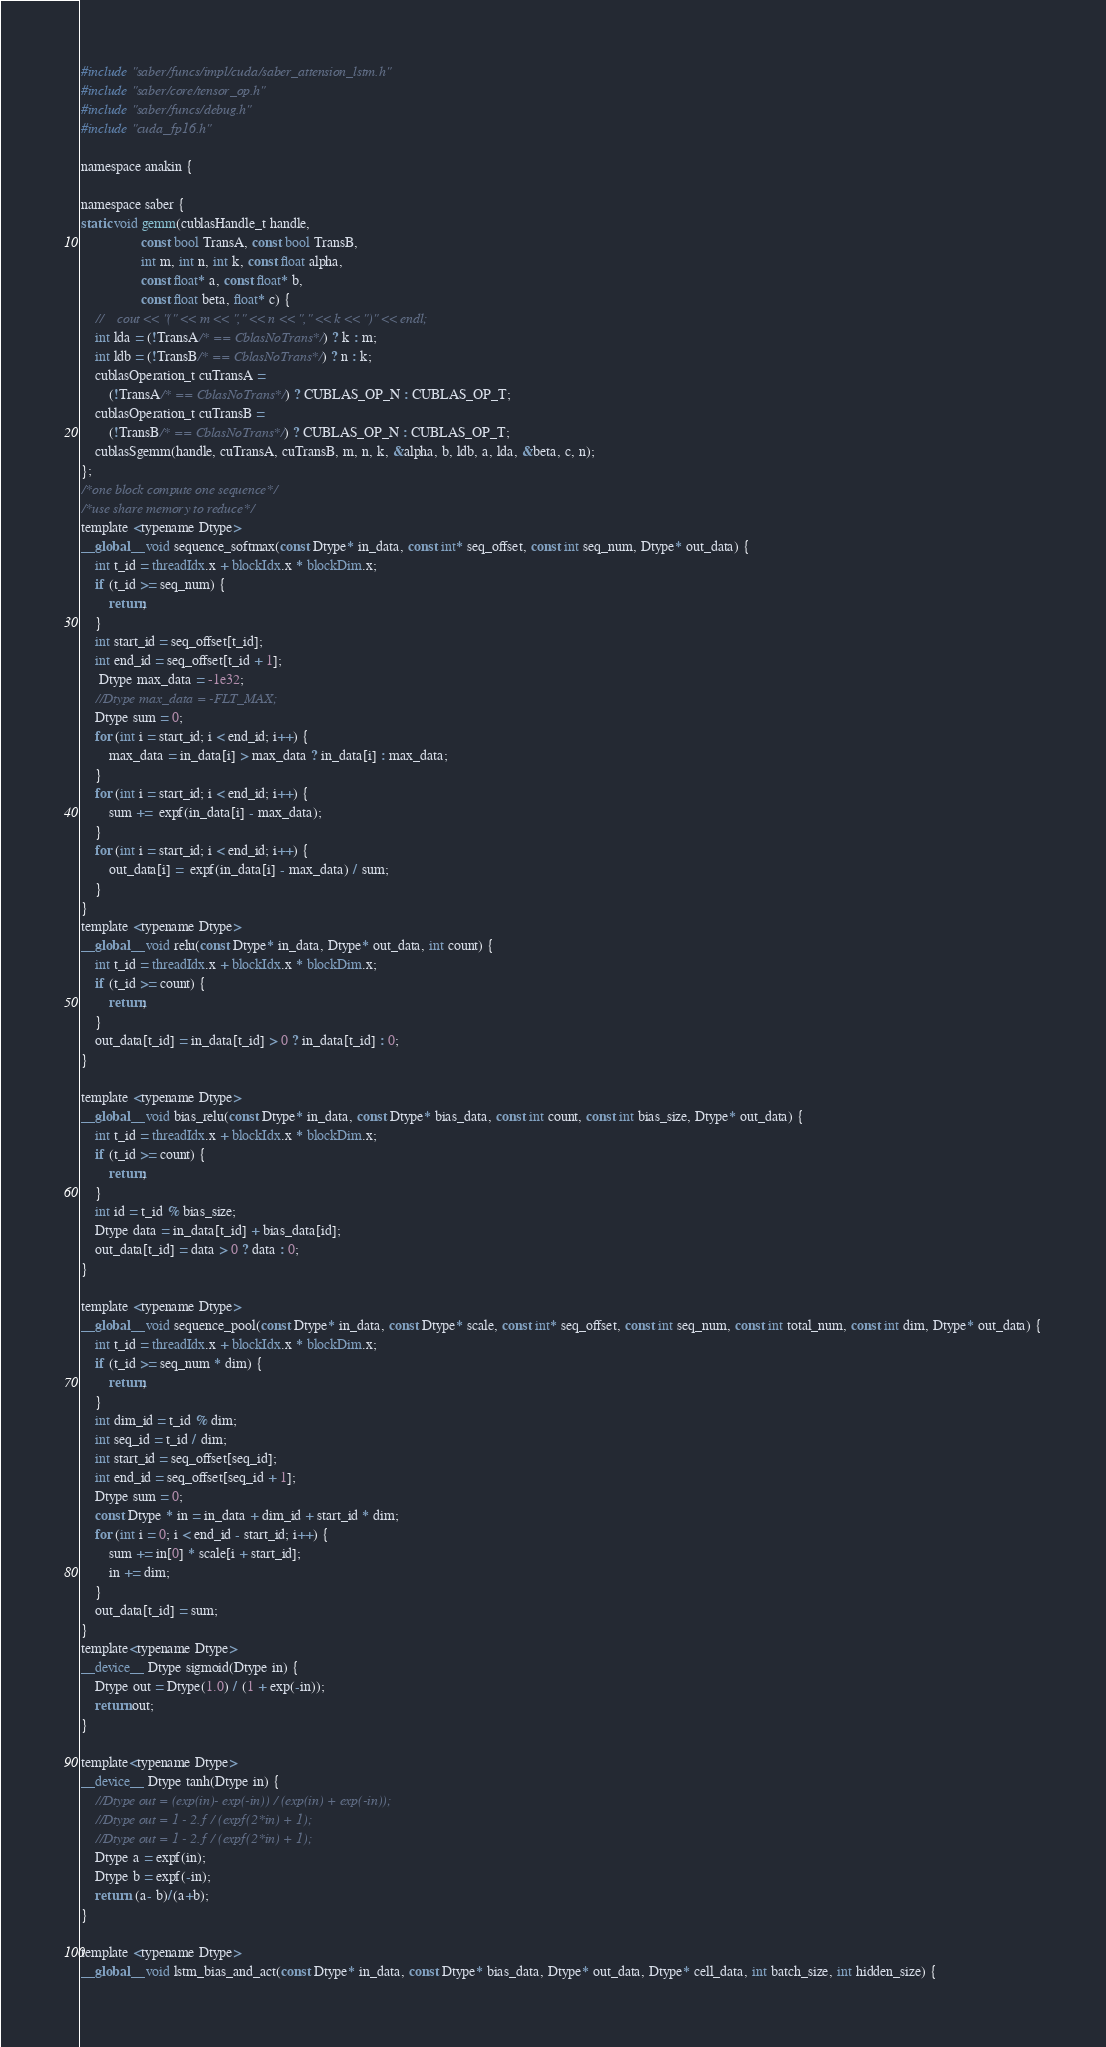Convert code to text. <code><loc_0><loc_0><loc_500><loc_500><_Cuda_>#include "saber/funcs/impl/cuda/saber_attension_lstm.h"
#include "saber/core/tensor_op.h"
#include "saber/funcs/debug.h"
#include "cuda_fp16.h"

namespace anakin {

namespace saber {
static void gemm(cublasHandle_t handle, 
                 const bool TransA, const bool TransB, 
                 int m, int n, int k, const float alpha,
                 const float* a, const float* b, 
                 const float beta, float* c) {
    //    cout << "(" << m << "," << n << "," << k << ")" << endl;
    int lda = (!TransA/* == CblasNoTrans*/) ? k : m;
    int ldb = (!TransB/* == CblasNoTrans*/) ? n : k;
    cublasOperation_t cuTransA =
        (!TransA/* == CblasNoTrans*/) ? CUBLAS_OP_N : CUBLAS_OP_T;
    cublasOperation_t cuTransB =
        (!TransB/* == CblasNoTrans*/) ? CUBLAS_OP_N : CUBLAS_OP_T;
    cublasSgemm(handle, cuTransA, cuTransB, m, n, k, &alpha, b, ldb, a, lda, &beta, c, n);
};
/*one block compute one sequence*/
/*use share memory to reduce*/
template <typename Dtype>
__global__ void sequence_softmax(const Dtype* in_data, const int* seq_offset, const int seq_num, Dtype* out_data) {
    int t_id = threadIdx.x + blockIdx.x * blockDim.x;
    if (t_id >= seq_num) {
        return;
    }
    int start_id = seq_offset[t_id];
    int end_id = seq_offset[t_id + 1];
     Dtype max_data = -1e32;
    //Dtype max_data = -FLT_MAX;
    Dtype sum = 0;
    for (int i = start_id; i < end_id; i++) {
        max_data = in_data[i] > max_data ? in_data[i] : max_data;
    }
    for (int i = start_id; i < end_id; i++) {
        sum +=  expf(in_data[i] - max_data);
    }
    for (int i = start_id; i < end_id; i++) {
        out_data[i] =  expf(in_data[i] - max_data) / sum;
    }
}
template <typename Dtype>
__global__ void relu(const Dtype* in_data, Dtype* out_data, int count) {
    int t_id = threadIdx.x + blockIdx.x * blockDim.x;
    if (t_id >= count) {
        return;
    }
    out_data[t_id] = in_data[t_id] > 0 ? in_data[t_id] : 0;
}

template <typename Dtype>
__global__ void bias_relu(const Dtype* in_data, const Dtype* bias_data, const int count, const int bias_size, Dtype* out_data) {
    int t_id = threadIdx.x + blockIdx.x * blockDim.x;
    if (t_id >= count) {
        return;
    }
    int id = t_id % bias_size;
    Dtype data = in_data[t_id] + bias_data[id]; 
    out_data[t_id] = data > 0 ? data : 0;
}

template <typename Dtype>
__global__ void sequence_pool(const Dtype* in_data, const Dtype* scale, const int* seq_offset, const int seq_num, const int total_num, const int dim, Dtype* out_data) {
    int t_id = threadIdx.x + blockIdx.x * blockDim.x;
    if (t_id >= seq_num * dim) {
        return;
    }
    int dim_id = t_id % dim;
    int seq_id = t_id / dim;
    int start_id = seq_offset[seq_id];
    int end_id = seq_offset[seq_id + 1];
    Dtype sum = 0;
    const Dtype * in = in_data + dim_id + start_id * dim;
    for (int i = 0; i < end_id - start_id; i++) {
        sum += in[0] * scale[i + start_id];
        in += dim;
    }
    out_data[t_id] = sum;
}
template<typename Dtype>
__device__ Dtype sigmoid(Dtype in) {
    Dtype out = Dtype(1.0) / (1 + exp(-in));
    return out;
}

template<typename Dtype>
__device__ Dtype tanh(Dtype in) {
    //Dtype out = (exp(in)- exp(-in)) / (exp(in) + exp(-in));
    //Dtype out = 1 - 2.f / (expf(2*in) + 1);
    //Dtype out = 1 - 2.f / (expf(2*in) + 1);
    Dtype a = expf(in);
    Dtype b = expf(-in);
    return  (a- b)/(a+b);
}

template <typename Dtype>
__global__ void lstm_bias_and_act(const Dtype* in_data, const Dtype* bias_data, Dtype* out_data, Dtype* cell_data, int batch_size, int hidden_size) {</code> 